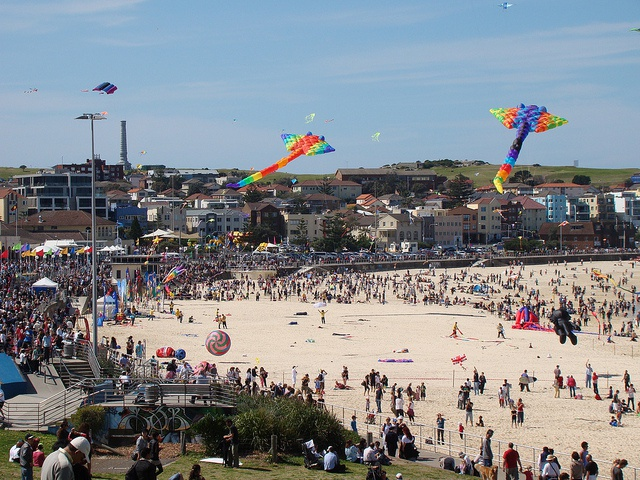Describe the objects in this image and their specific colors. I can see people in lightblue, black, lightgray, tan, and gray tones, kite in lightblue, black, darkgray, gray, and blue tones, kite in lightblue, red, salmon, and orange tones, people in lightblue, black, gray, darkgray, and lightgray tones, and sports ball in lightblue, gray, brown, salmon, and lightpink tones in this image. 